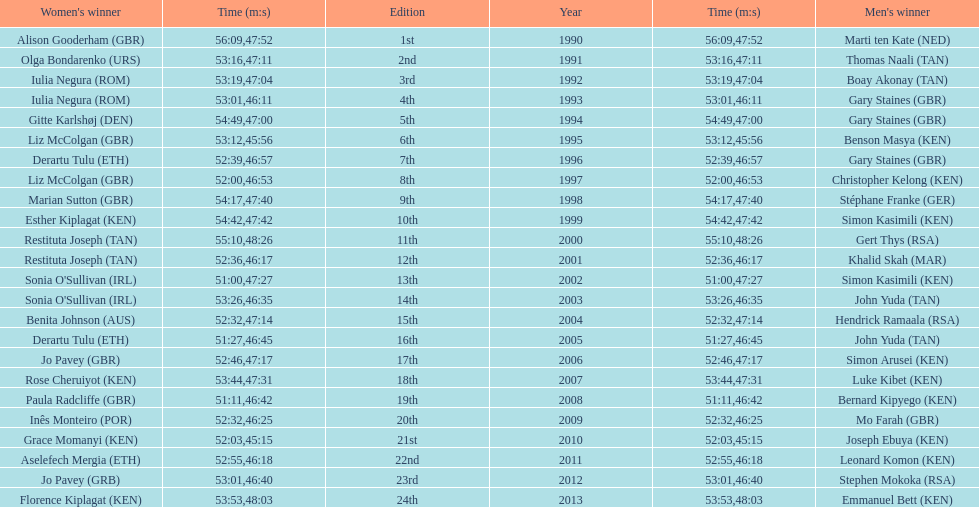How many men winners had times at least 46 minutes or under? 2. 